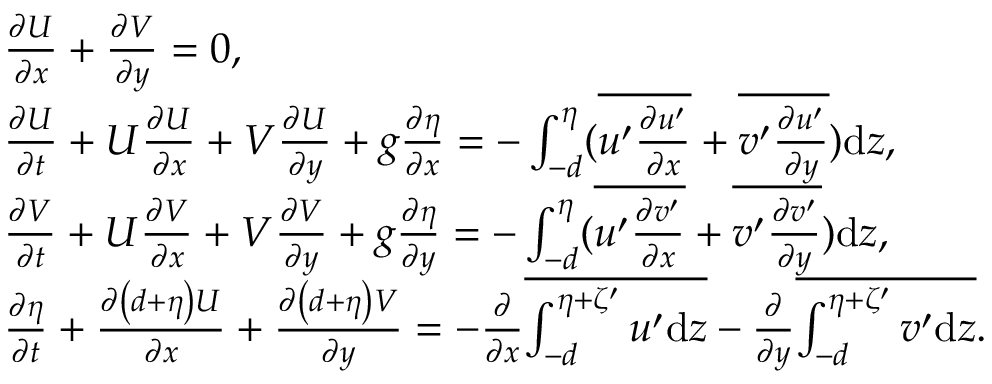<formula> <loc_0><loc_0><loc_500><loc_500>\begin{array} { r l } & { \frac { \partial U } { \partial x } + \frac { \partial V } { \partial y } = 0 , } \\ & { \frac { \partial U } { \partial t } + U \frac { \partial U } { \partial x } + V \frac { \partial U } { \partial y } + g \frac { \partial \eta } { \partial x } = - \int _ { - d } ^ { \eta } ( \overline { { u ^ { \prime } \frac { \partial u ^ { \prime } } { \partial x } } } + \overline { { v ^ { \prime } \frac { \partial u ^ { \prime } } { \partial y } } } ) d z , } \\ & { \frac { \partial V } { \partial t } + U \frac { \partial V } { \partial x } + V \frac { \partial V } { \partial y } + g \frac { \partial \eta } { \partial y } = - \int _ { - d } ^ { \eta } ( \overline { { u ^ { \prime } \frac { \partial v ^ { \prime } } { \partial x } } } + \overline { { v ^ { \prime } \frac { \partial v ^ { \prime } } { \partial y } } } ) d z , } \\ & { \frac { \partial \eta } { \partial t } + \frac { \partial \left ( d + \eta \right ) U } { \partial x } + \frac { \partial \left ( d + \eta \right ) V } { \partial y } = - \frac { \partial } { \partial x } \overline { { \int _ { - d } ^ { \eta + \zeta ^ { \prime } } u ^ { \prime } d z } } - \frac { \partial } { \partial y } \overline { { \int _ { - d } ^ { \eta + \zeta ^ { \prime } } v ^ { \prime } d z } } . } \end{array}</formula> 